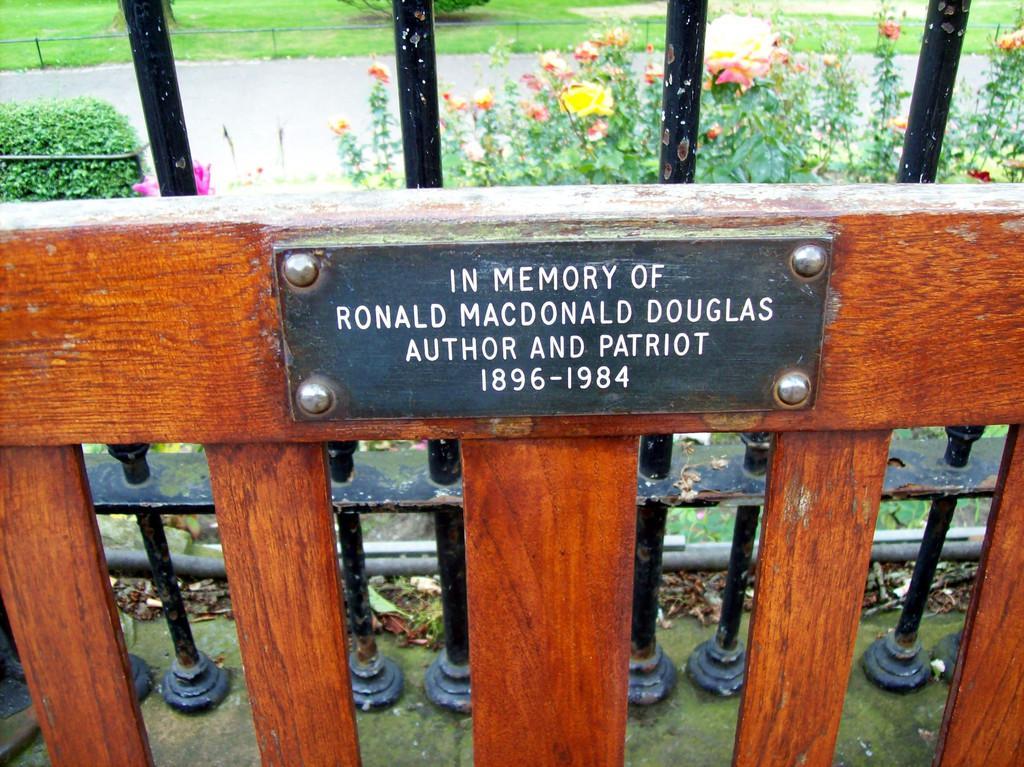In one or two sentences, can you explain what this image depicts? In this picture I can see the wooden thing in front on which there is a plate and I see something is written on it and behind it I see few rods and in the middle of this picture I see plants and I see few flowers. In the background I see the grass. 